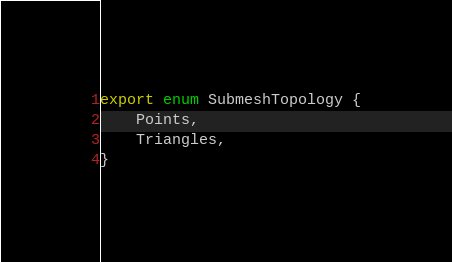<code> <loc_0><loc_0><loc_500><loc_500><_TypeScript_>export enum SubmeshTopology {
	Points,
	Triangles,
}
</code> 